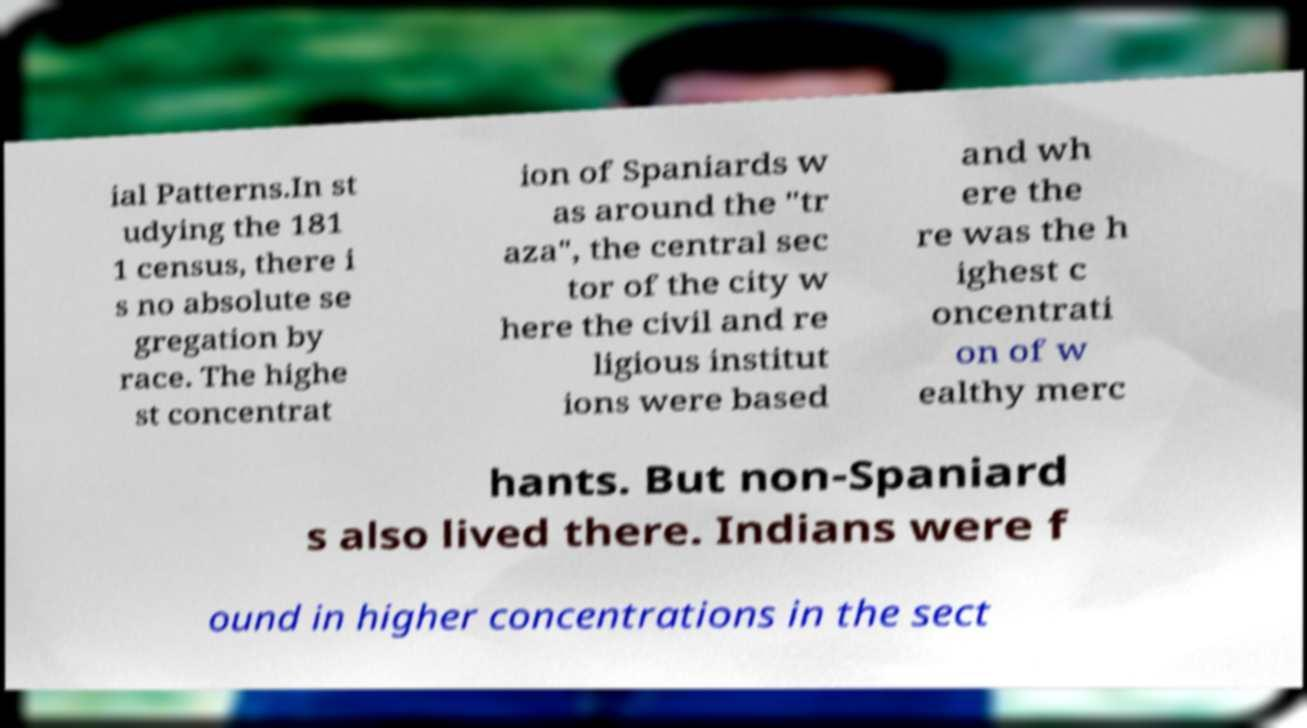Could you extract and type out the text from this image? ial Patterns.In st udying the 181 1 census, there i s no absolute se gregation by race. The highe st concentrat ion of Spaniards w as around the "tr aza", the central sec tor of the city w here the civil and re ligious institut ions were based and wh ere the re was the h ighest c oncentrati on of w ealthy merc hants. But non-Spaniard s also lived there. Indians were f ound in higher concentrations in the sect 